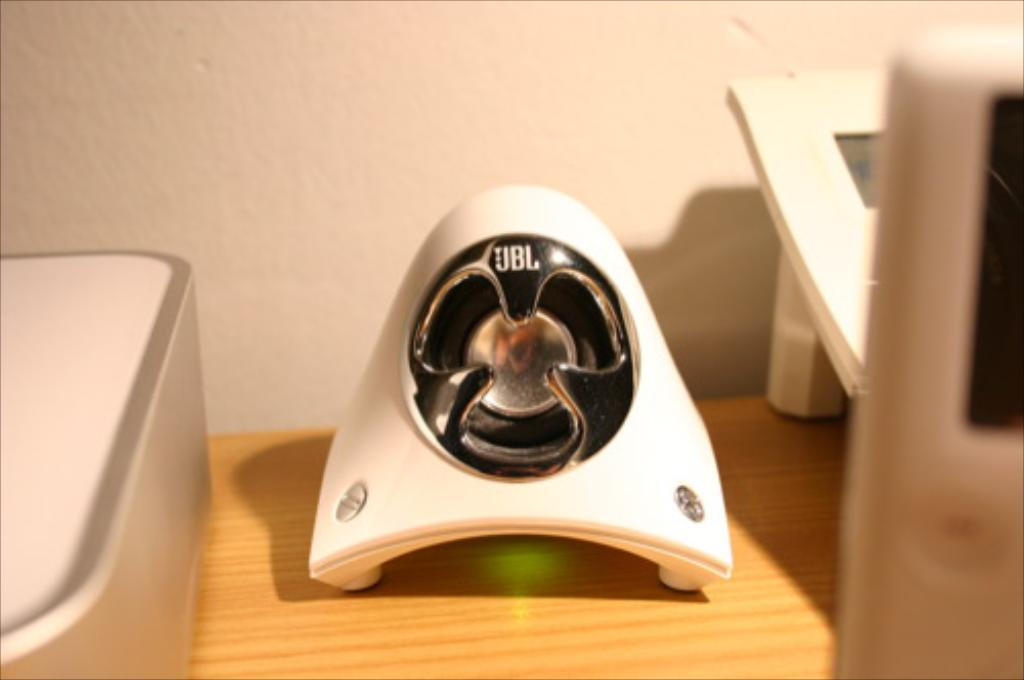What is the main object in the picture? There is a white collar device in the picture. Can you describe any specific features of the device? The device has a logo on it. Where is the device located in the image? The device is placed on a wooden table. What can be seen in the background of the picture? There is a wall in the background of the picture. Reasoning: Let's think step by step by step in order to produce the conversation. We start by identifying the main object in the image, which is the white collar device. Then, we describe specific features of the device, such as the logo. Next, we mention the location of the device, which is on a wooden table. Finally, we acknowledge the presence of a wall in the background of the image. Absurd Question/Answer: How does the device help with digestion in the image? The image does not show the device being used for digestion, nor does it provide any information about its function related to digestion. 